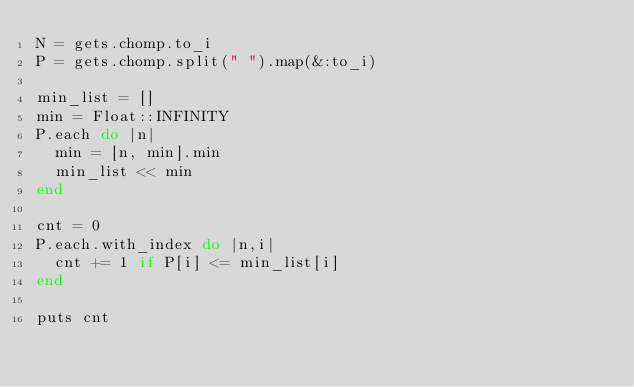Convert code to text. <code><loc_0><loc_0><loc_500><loc_500><_Ruby_>N = gets.chomp.to_i
P = gets.chomp.split(" ").map(&:to_i)

min_list = []
min = Float::INFINITY
P.each do |n|
  min = [n, min].min
  min_list << min
end

cnt = 0
P.each.with_index do |n,i|
  cnt += 1 if P[i] <= min_list[i]
end

puts cnt</code> 